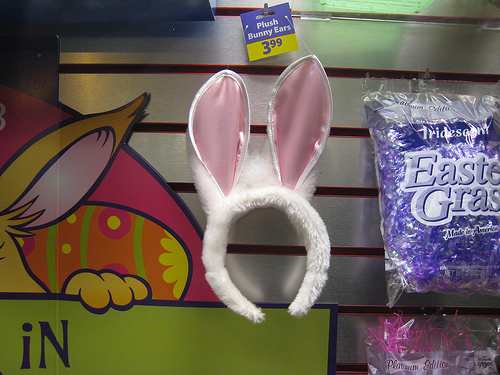<image>
Can you confirm if the bunny ears is to the right of the easter bag? No. The bunny ears is not to the right of the easter bag. The horizontal positioning shows a different relationship. 